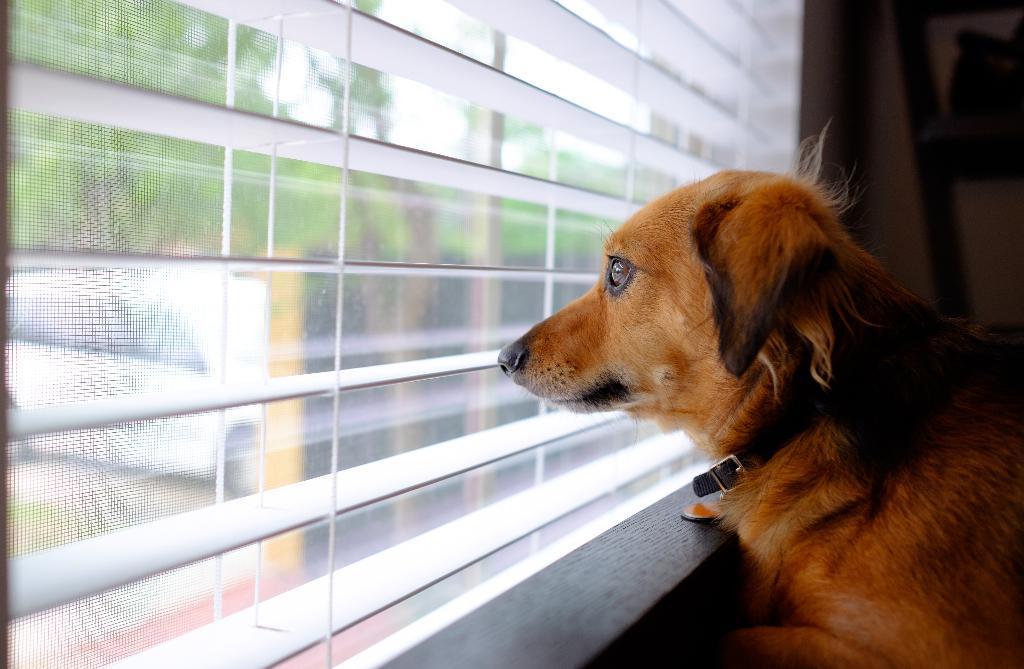Describe this image in one or two sentences. There is a dog, in front of this dog we can see glass window, through this glass window we can see trees,car and sky. 